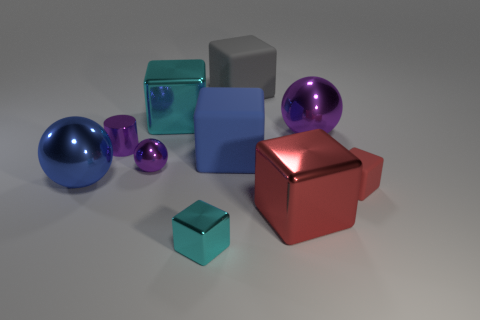Subtract all cyan cubes. How many cubes are left? 4 Subtract all red rubber cubes. How many cubes are left? 5 Subtract all yellow blocks. Subtract all gray balls. How many blocks are left? 6 Subtract all balls. How many objects are left? 7 Add 6 red metallic blocks. How many red metallic blocks exist? 7 Subtract 0 cyan cylinders. How many objects are left? 10 Subtract all small purple metallic balls. Subtract all small cyan shiny things. How many objects are left? 8 Add 2 cubes. How many cubes are left? 8 